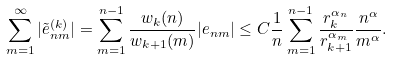<formula> <loc_0><loc_0><loc_500><loc_500>\sum _ { m = 1 } ^ { \infty } | \tilde { e } ^ { ( k ) } _ { n m } | = \sum _ { m = 1 } ^ { n - 1 } \frac { w _ { k } ( n ) } { w _ { k + 1 } ( m ) } | e _ { n m } | \leq C \frac { 1 } { n } \sum _ { m = 1 } ^ { n - 1 } \frac { r _ { k } ^ { \alpha _ { n } } } { r _ { k + 1 } ^ { \alpha _ { m } } } \frac { n ^ { \alpha } } { m ^ { \alpha } } .</formula> 